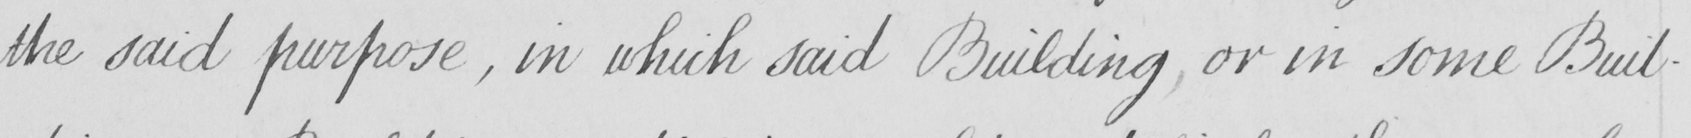What is written in this line of handwriting? the said purpose , in which said Building or in some Buil- 